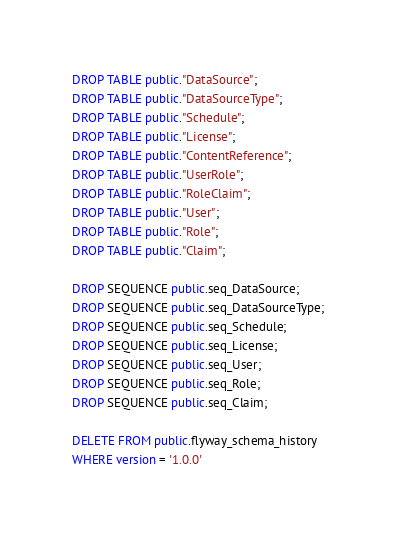Convert code to text. <code><loc_0><loc_0><loc_500><loc_500><_SQL_>DROP TABLE public."DataSource";
DROP TABLE public."DataSourceType";
DROP TABLE public."Schedule";
DROP TABLE public."License";
DROP TABLE public."ContentReference";
DROP TABLE public."UserRole";
DROP TABLE public."RoleClaim";
DROP TABLE public."User";
DROP TABLE public."Role";
DROP TABLE public."Claim";

DROP SEQUENCE public.seq_DataSource;
DROP SEQUENCE public.seq_DataSourceType;
DROP SEQUENCE public.seq_Schedule;
DROP SEQUENCE public.seq_License;
DROP SEQUENCE public.seq_User;
DROP SEQUENCE public.seq_Role;
DROP SEQUENCE public.seq_Claim;

DELETE FROM public.flyway_schema_history
WHERE version = '1.0.0'</code> 